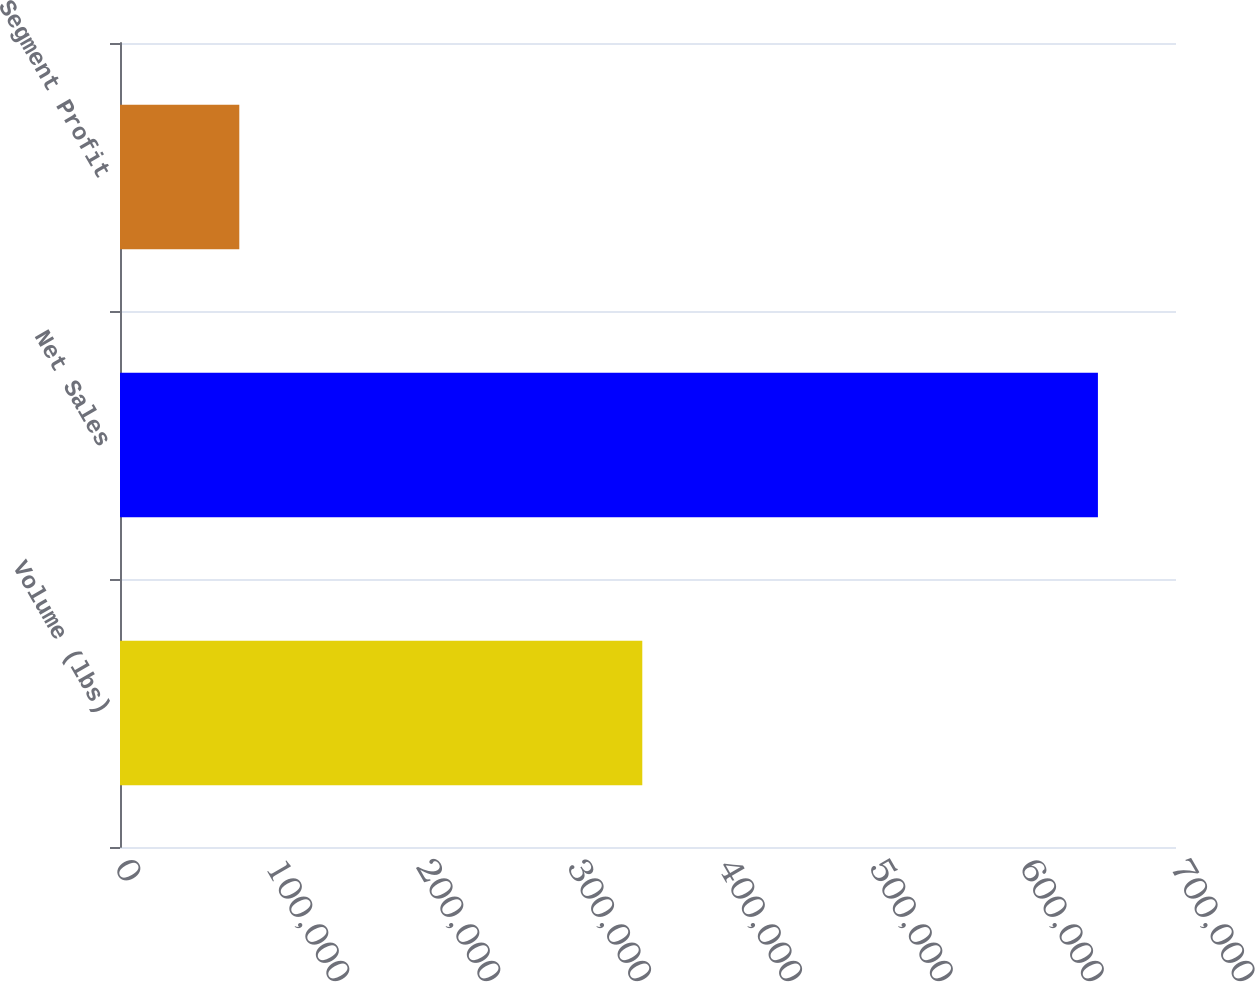Convert chart to OTSL. <chart><loc_0><loc_0><loc_500><loc_500><bar_chart><fcel>Volume (lbs)<fcel>Net Sales<fcel>Segment Profit<nl><fcel>346214<fcel>648244<fcel>79082<nl></chart> 